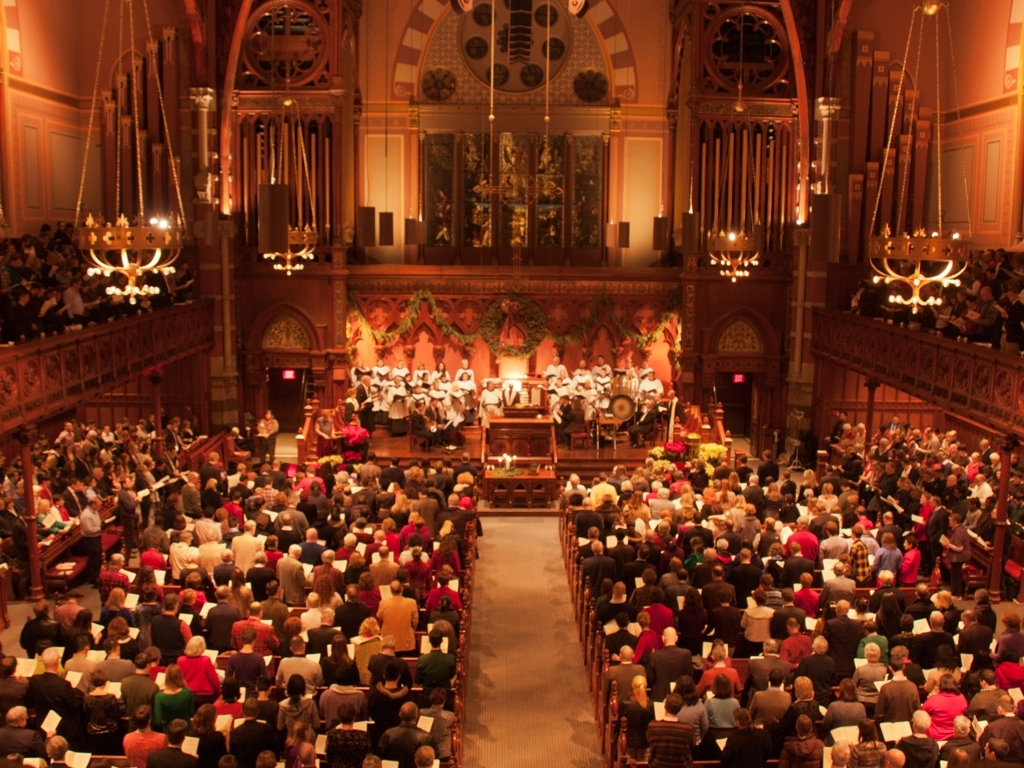Is the quality of this image good? The image is clear with good lighting, capturing the ambience of the event. There's a warm tone to the photo, and the angle offers a comprehensive view of the venue, including the audience, choir, and architectural details. However, it does seem to lack sharpness when closely observed, especially around the edges. Therefore, while the overall composition is pleasing, the sharpness could be improved. 